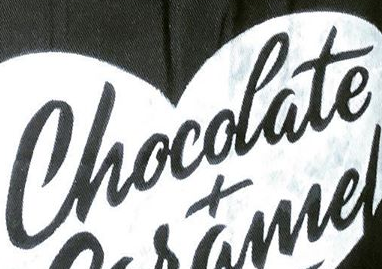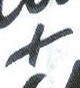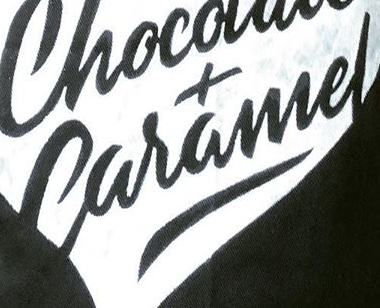Read the text content from these images in order, separated by a semicolon. Chocolate; +; Caramel 